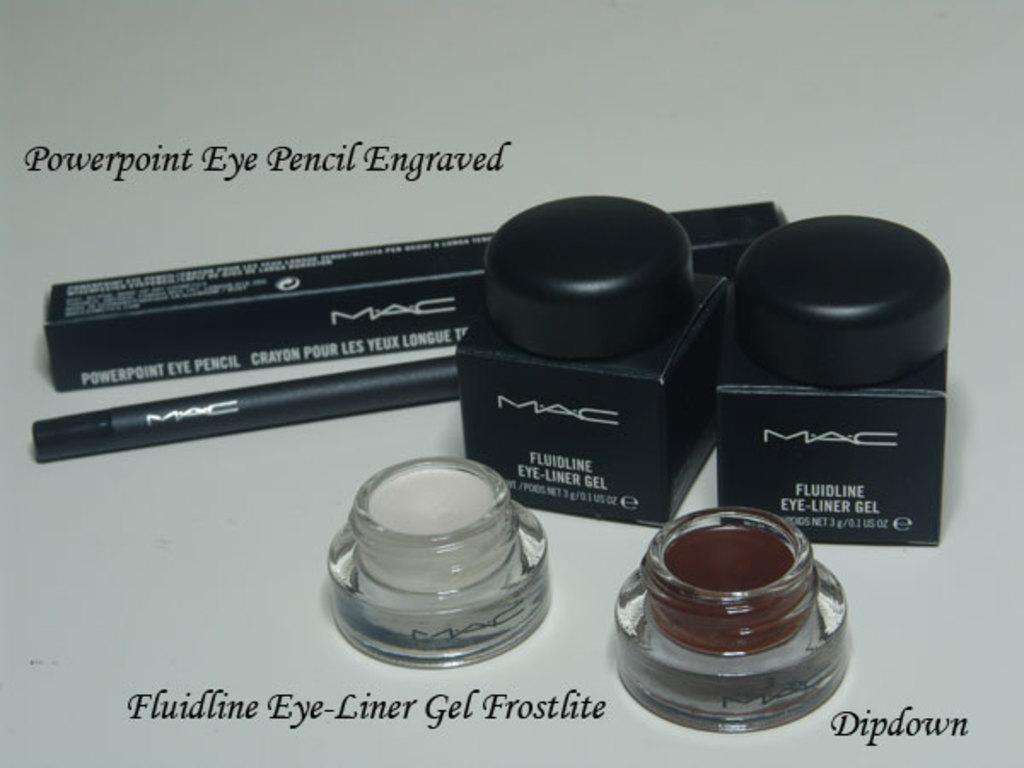What is the brand of these cosmetics?
Provide a succinct answer. Mac. What is the color of the eye-liner gel?
Provide a succinct answer. Frostlite. 